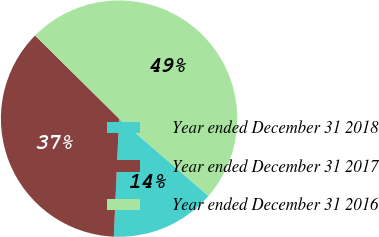Convert chart to OTSL. <chart><loc_0><loc_0><loc_500><loc_500><pie_chart><fcel>Year ended December 31 2018<fcel>Year ended December 31 2017<fcel>Year ended December 31 2016<nl><fcel>14.36%<fcel>36.7%<fcel>48.94%<nl></chart> 